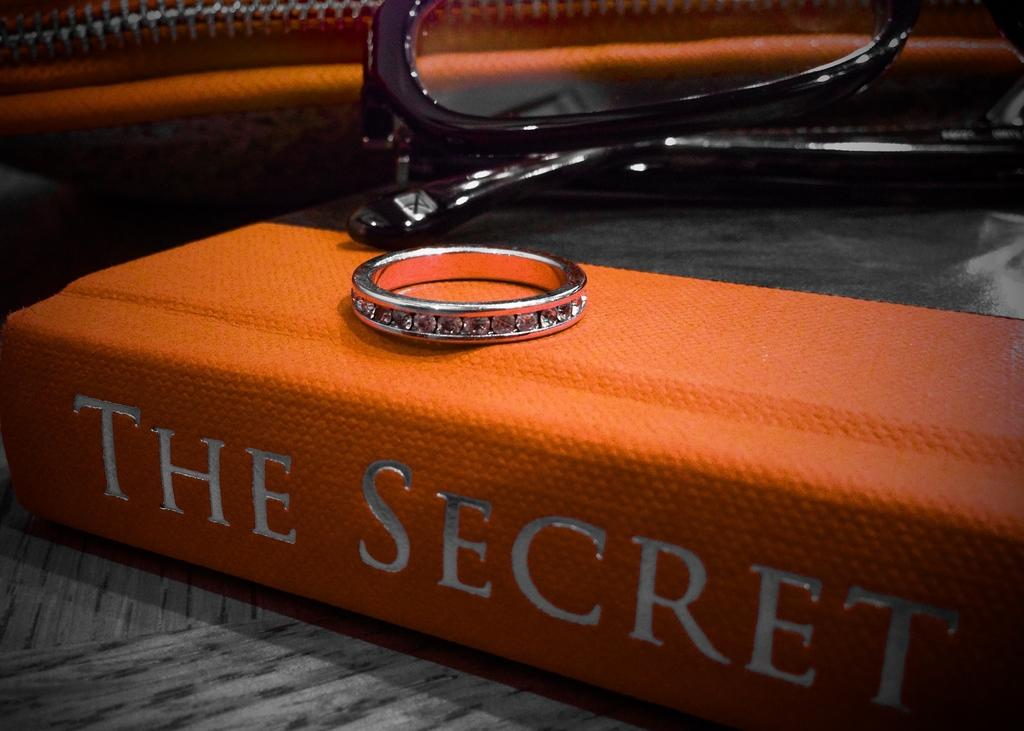What type of accessory is present in the image? There is a ring in the image. What objects are used for vision in the image? There are glasses in the image. What type of personal item is visible in the image? There is a purse in the image. What is the book in the image used for? The book in the image is used for reading. On what surface is the book placed? The book is placed on a surface. What type of net can be seen in the image? There is no net present in the image. What design is featured on the ring in the image? The provided facts do not mention any specific design on the ring in the image. 